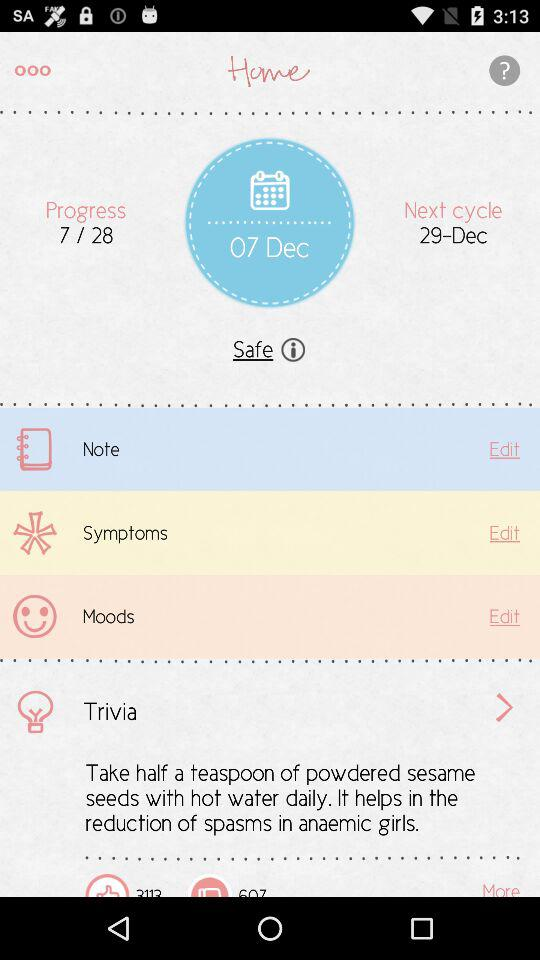What is the next cycle date? The date for the next cycle is December 29. 